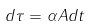Convert formula to latex. <formula><loc_0><loc_0><loc_500><loc_500>d \tau = \alpha A d t</formula> 